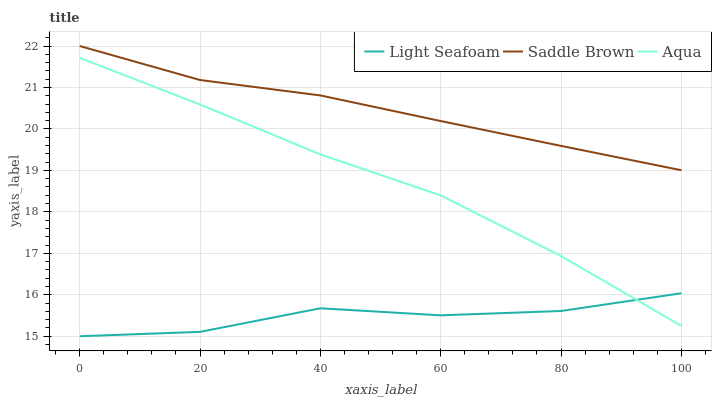Does Light Seafoam have the minimum area under the curve?
Answer yes or no. Yes. Does Saddle Brown have the maximum area under the curve?
Answer yes or no. Yes. Does Aqua have the minimum area under the curve?
Answer yes or no. No. Does Aqua have the maximum area under the curve?
Answer yes or no. No. Is Saddle Brown the smoothest?
Answer yes or no. Yes. Is Light Seafoam the roughest?
Answer yes or no. Yes. Is Aqua the smoothest?
Answer yes or no. No. Is Aqua the roughest?
Answer yes or no. No. Does Light Seafoam have the lowest value?
Answer yes or no. Yes. Does Aqua have the lowest value?
Answer yes or no. No. Does Saddle Brown have the highest value?
Answer yes or no. Yes. Does Aqua have the highest value?
Answer yes or no. No. Is Aqua less than Saddle Brown?
Answer yes or no. Yes. Is Saddle Brown greater than Aqua?
Answer yes or no. Yes. Does Light Seafoam intersect Aqua?
Answer yes or no. Yes. Is Light Seafoam less than Aqua?
Answer yes or no. No. Is Light Seafoam greater than Aqua?
Answer yes or no. No. Does Aqua intersect Saddle Brown?
Answer yes or no. No. 